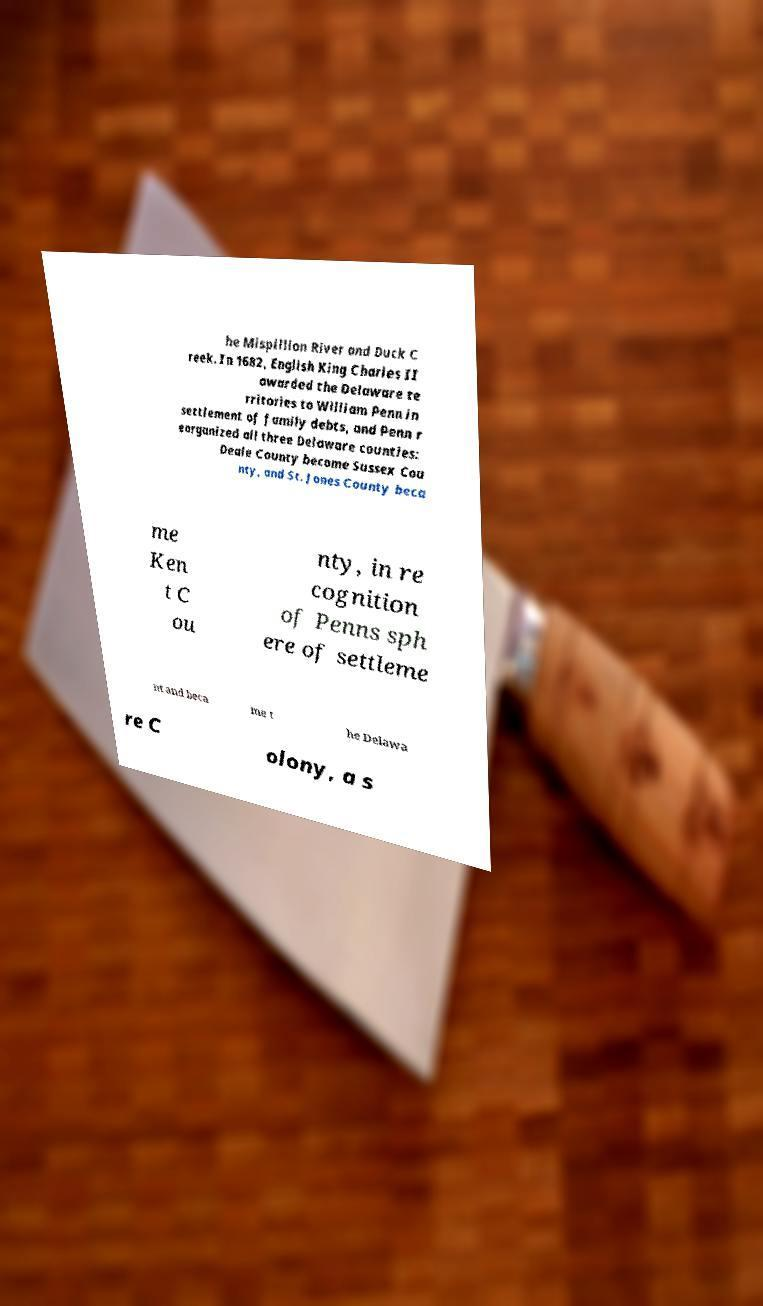Please identify and transcribe the text found in this image. he Mispillion River and Duck C reek. In 1682, English King Charles II awarded the Delaware te rritories to William Penn in settlement of family debts, and Penn r eorganized all three Delaware counties: Deale County become Sussex Cou nty, and St. Jones County beca me Ken t C ou nty, in re cognition of Penns sph ere of settleme nt and beca me t he Delawa re C olony, a s 